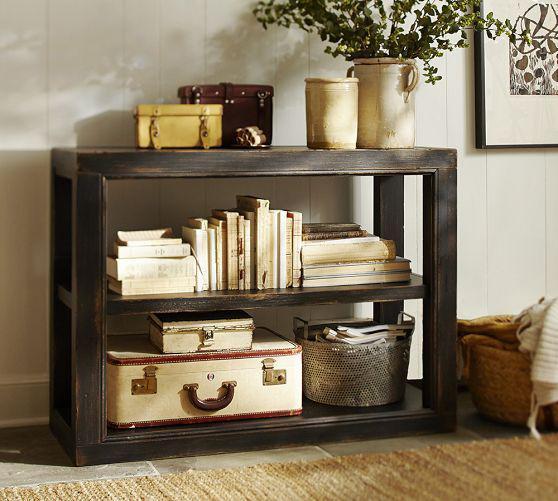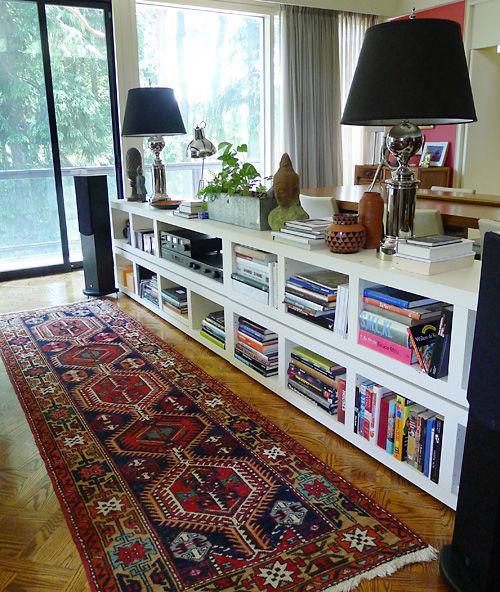The first image is the image on the left, the second image is the image on the right. Considering the images on both sides, is "There is a plant on top of a shelf in at least one of the images." valid? Answer yes or no. Yes. 